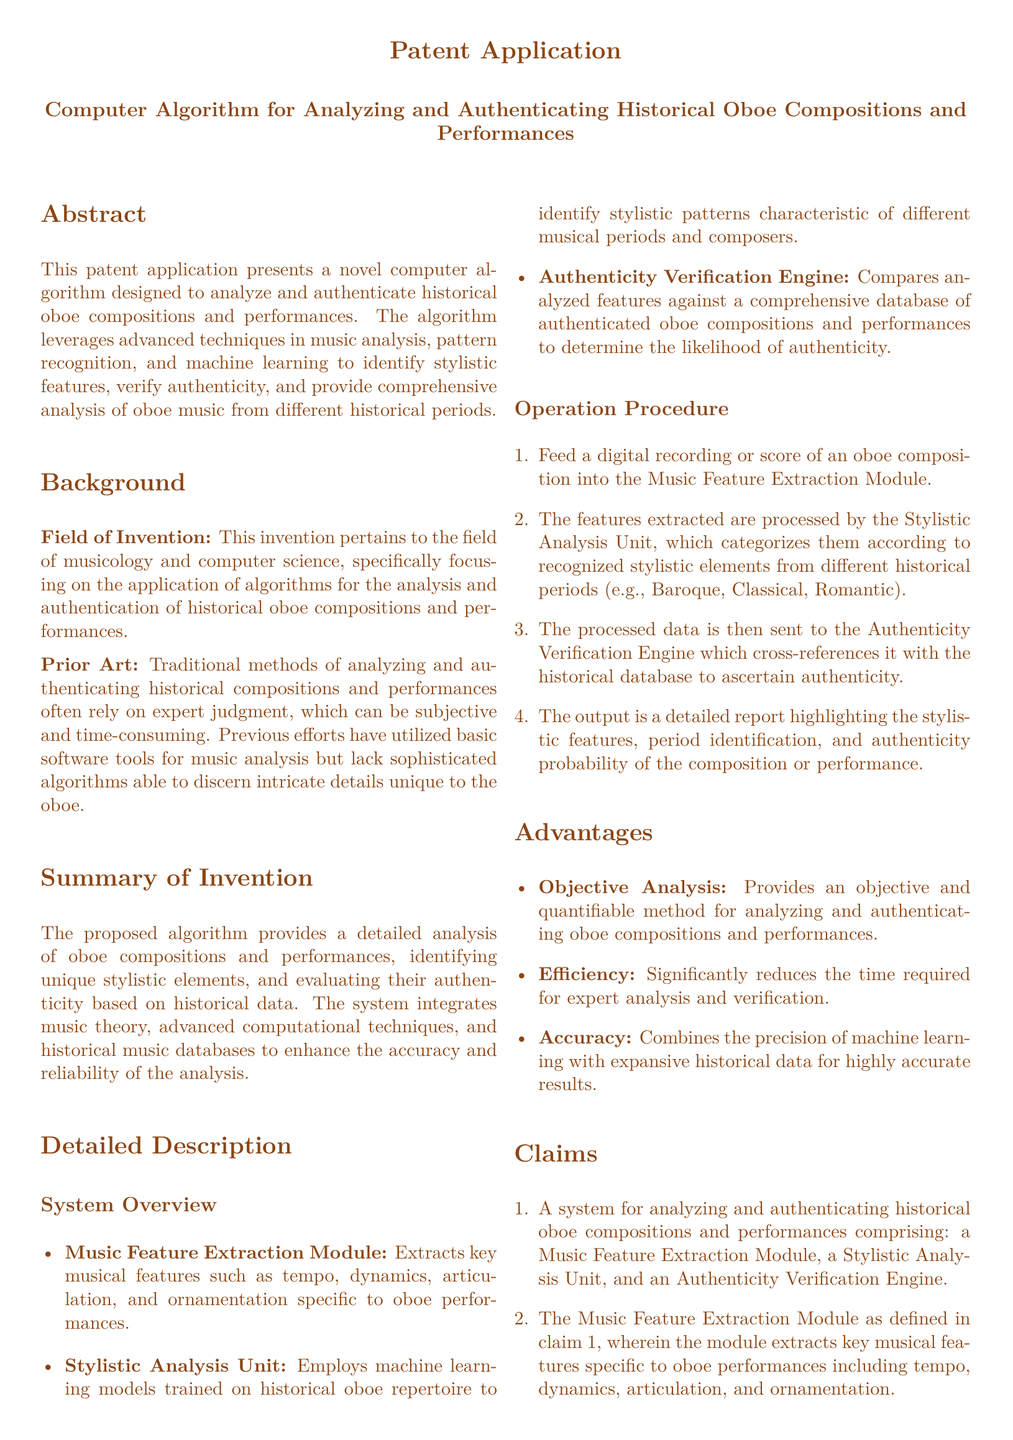What is the title of the patent application? The title is the main identification for the patent application, which is specified in the document.
Answer: Computer Algorithm for Analyzing and Authenticating Historical Oboe Compositions and Performances What is the main objective of the proposed algorithm? The main objective is stated explicitly in the abstract section, which summarizes the purpose of the algorithm.
Answer: To analyze and authenticate historical oboe compositions and performances What does the Music Feature Extraction Module extract? The module's functionality is outlined in the detailed description, specifically mentioning key musical features.
Answer: Key musical features such as tempo, dynamics, articulation, and ornamentation What type of analysis does the Stylistic Analysis Unit perform? The functionality of the Stylistic Analysis Unit is described under the system overview section, highlighting its analytical role.
Answer: Stylistic analysis characteristic of different musical periods and composers In which section do the claims appear? The claims section is an important part of patent documents where the invention's specifics are outlined.
Answer: Claims How many claims are detailed in the patent application? The total number of claims is stated in the claims section, indicating the patent's scope.
Answer: Four claims What is a key advantage of the proposed system? Advantages are listed in the document, pointing to the benefits provided by the system.
Answer: Objective analysis Who are the intended users of the algorithm? The intended users can generally be inferred from the document's focus on music analysis, particularly oboe.
Answer: Musicologists and oboe specialists What technology does the algorithm incorporate for analysis? The document specifies the advanced techniques used in the algorithm, reflecting its technological foundation.
Answer: Machine learning 